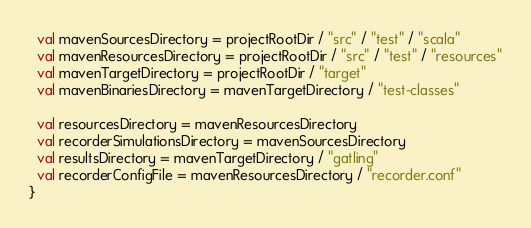<code> <loc_0><loc_0><loc_500><loc_500><_Scala_>
  val mavenSourcesDirectory = projectRootDir / "src" / "test" / "scala"
  val mavenResourcesDirectory = projectRootDir / "src" / "test" / "resources"
  val mavenTargetDirectory = projectRootDir / "target"
  val mavenBinariesDirectory = mavenTargetDirectory / "test-classes"

  val resourcesDirectory = mavenResourcesDirectory
  val recorderSimulationsDirectory = mavenSourcesDirectory
  val resultsDirectory = mavenTargetDirectory / "gatling"
  val recorderConfigFile = mavenResourcesDirectory / "recorder.conf"
}</code> 